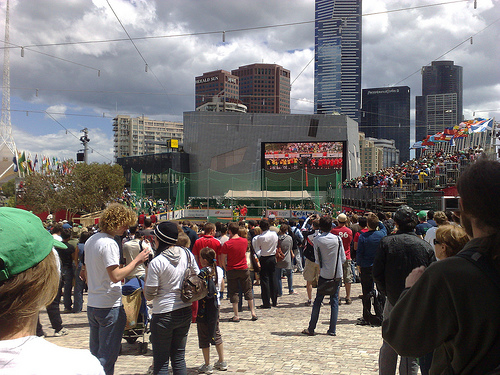<image>
Can you confirm if the people is behind the building? No. The people is not behind the building. From this viewpoint, the people appears to be positioned elsewhere in the scene. 